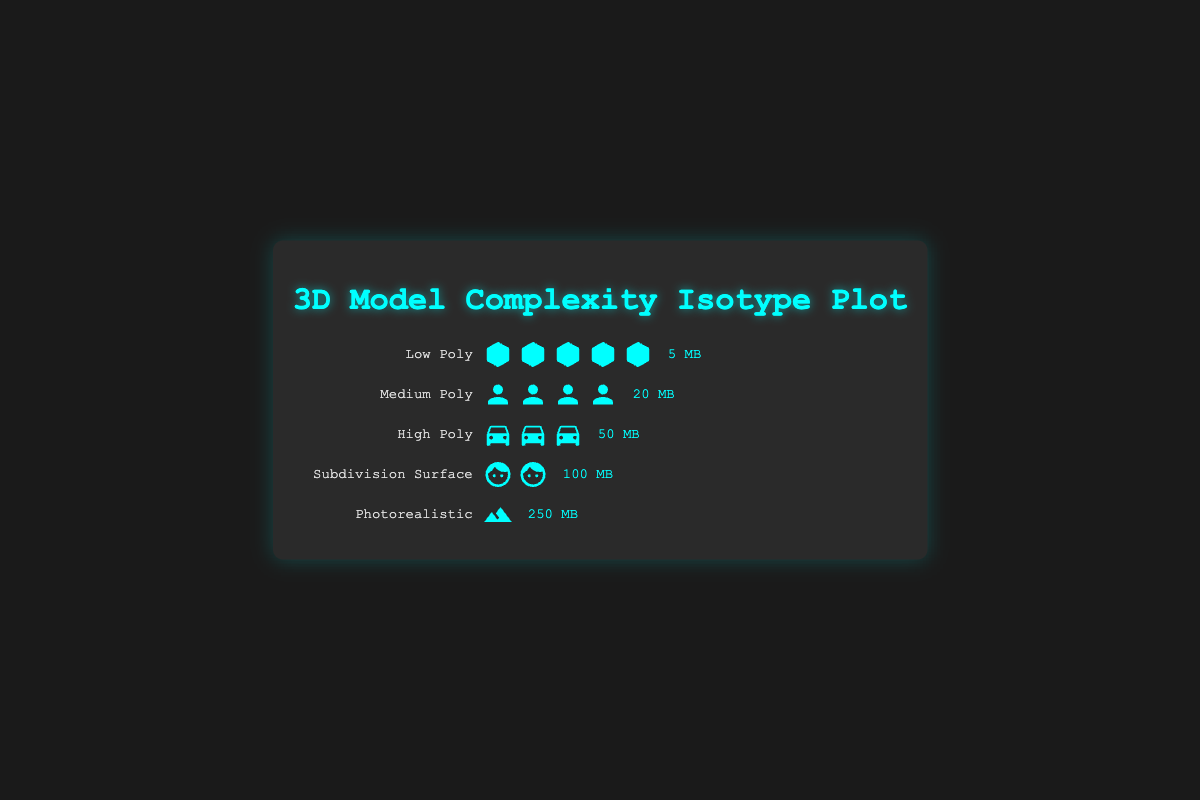What's the title of the figure? The title of the figure is written at the top of the display box in large, prominent letters. It can be read directly.
Answer: 3D Model Complexity Isotype Plot How many icons represent the Low Poly model complexity? The Low Poly row has a label and to its right, there are several cube icons that can be counted visually.
Answer: 5 What is the file size for the Photorealistic model complexity? The Photorealistic row has a single landscape icon and the file size is noted at the right end of the row.
Answer: 250 MB Which model complexity has the highest file size? To determine the highest file size, compare the file sizes listed for each row. Photorealistic has the highest file size.
Answer: Photorealistic What is the total number of icons in the High Poly row? Count the number of vehicle icons in the High Poly row from left to right.
Answer: 3 How many times larger is the file size of Subdivision Surface models compared to Low Poly models? First find file sizes of both Subdivision Surface (100 MB) and Low Poly (5 MB). Then divide the Subdivision Surface file size by the Low Poly file size to find the factor.
Answer: 20 Which model complexities have file sizes greater than or equal to 50 MB? Compare each model's file size and list those that are 50 MB or more: High Poly (50 MB), Subdivision Surface (100 MB), and Photorealistic (250 MB).
Answer: High Poly, Subdivision Surface, Photorealistic How many more MB is the file size of the Photorealistic model compared to the Medium Poly model? Subtract the file size of the Medium Poly model (20 MB) from the Photorealistic model (250 MB).
Answer: 230 MB What type of icons are used to represent the Medium Poly model? Look at the icons on the Medium Poly row which can be visually identified.
Answer: Character icons If you sum up the file sizes for Low Poly and High Poly models, what do you get? Add the file sizes for Low Poly (5 MB) and High Poly (50 MB): 5 + 50.
Answer: 55 MB 